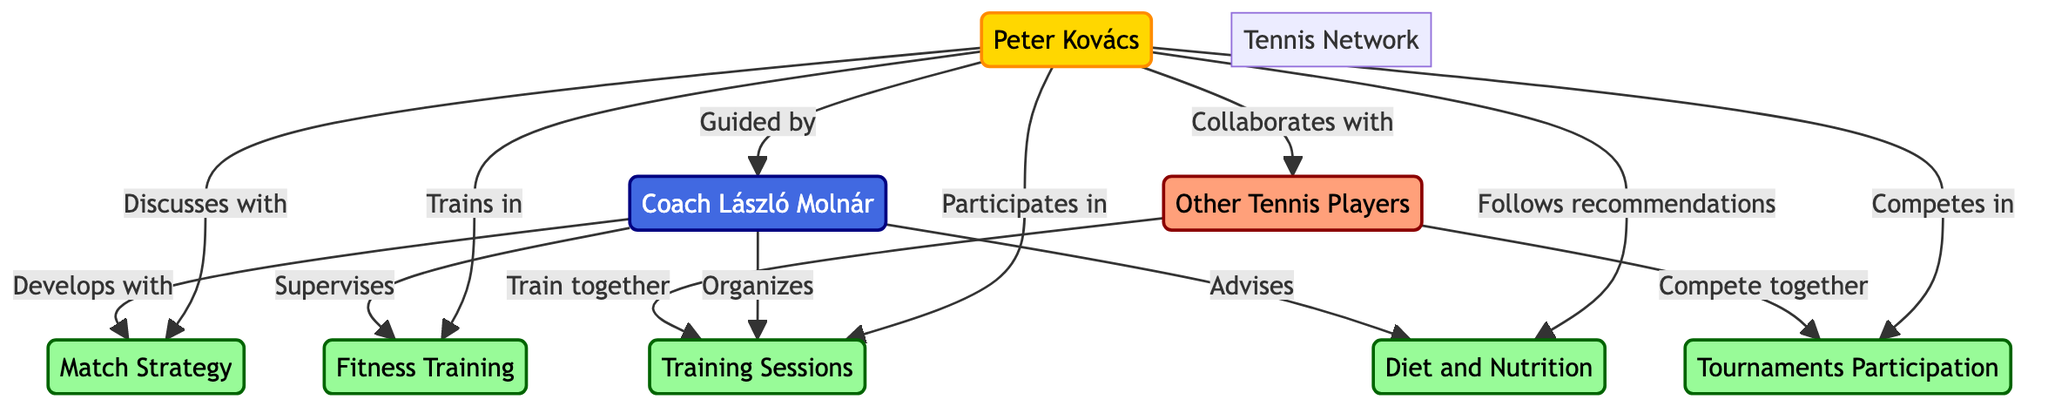What is the label of the player in the diagram? The diagram specifies a node labeled "Player" with the name "Peter Kovács" associated with it. Hence, the label of the player is directly identifiable.
Answer: Peter Kovács Who guides the player in the diagram? The edge connected to the "Player" node indicates a relationship labeled "Guided by", pointing to the "Coach" node. Therefore, the coach guides the player.
Answer: Coach László Molnár How many activities are represented in the diagram? By counting the distinct activity nodes such as Match Strategy, Training Sessions, Tournaments Participation, Fitness Training, and Diet and Nutrition, we find there are a total of five activities represented in the diagram.
Answer: 5 Which entity participates in training sessions? The edge coming out from the "Player" node and labeled "Participates in" points to the "Training" node. This shows that the player is the one participating in training sessions.
Answer: Peter Kovács What is the relationship between the player and other tennis players? The diagram displays a directed edge labeled "Collaborates with" from the "Player" to the "Peers" node, indicating a collaboration between the player and other tennis players.
Answer: Collaborates with Which entity supervises fitness training? The edge from the "Coach" node labeled "Supervises" directly points to the "Fitness" node, which shows that the coach is the entity responsible for supervising fitness training.
Answer: Coach László Molnár Do other tennis players compete together with the player in tournaments? The edge from "Peers" labeled "Compete together" connects to the "Tournaments" node, which shows that other tennis players do indeed compete together in tournaments.
Answer: Yes How does the coach contribute to match strategy development? The diagram shows an edge from the "Coach" node to the "Strategy" node labeled "Develops with". This illustrates that the coach plays a role in the development of match strategies.
Answer: Develops with What type of network is represented in this diagram? The diagram is a directed graph showcasing the relationships and collaborations within a network of a tennis player, coach, activities, and peers. This type indicates the directional nature of the connections between different entities.
Answer: Directed Graph 